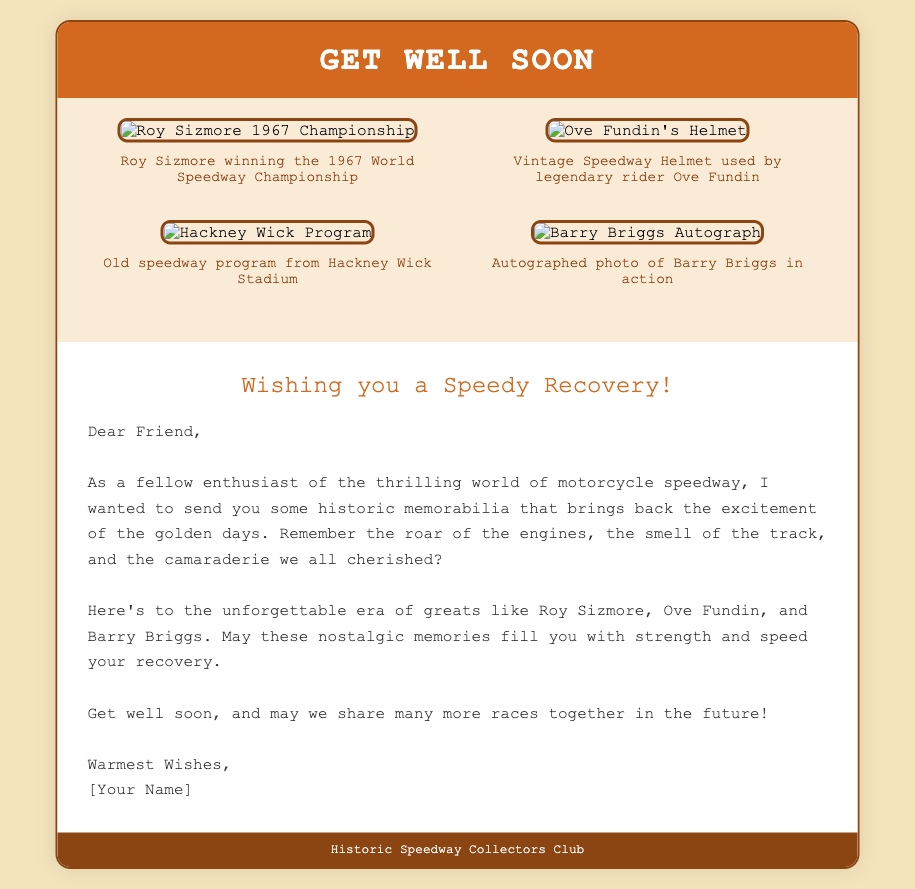What is the title of the card? The title is prominently displayed on the card cover, stating the purpose of the card.
Answer: Get Well Soon Who is featured in the 1967 Championship image? The image is specifically labeled with the name of the rider associated with this notable event.
Answer: Roy Sizmore What color is the card's background? The background color of the entire card is described in the styling section.
Answer: #f4e4bc Which legendary rider's helmet is shown in the collage? The name of the rider associated with the helmet is mentioned in the description below the image.
Answer: Ove Fundin What is the greeting message at the top of the message body? The message begins with the name of the recipient's well-wishing sentiment.
Answer: Wishing you a Speedy Recovery! How many collage items are there in total? The total number of collage items is counted from the visual elements shown on the card.
Answer: Four What is the closing line of the message? The final sentence of the message provides well-wishes and expresses hope for future meetings.
Answer: Warmest Wishes Which club is mentioned in the footer? The footer contains the name of the organization that produced this card.
Answer: Historic Speedway Collectors Club What year was the World Speedway Championship that is depicted? The event referenced in the image is linked to a specific year in its title.
Answer: 1967 